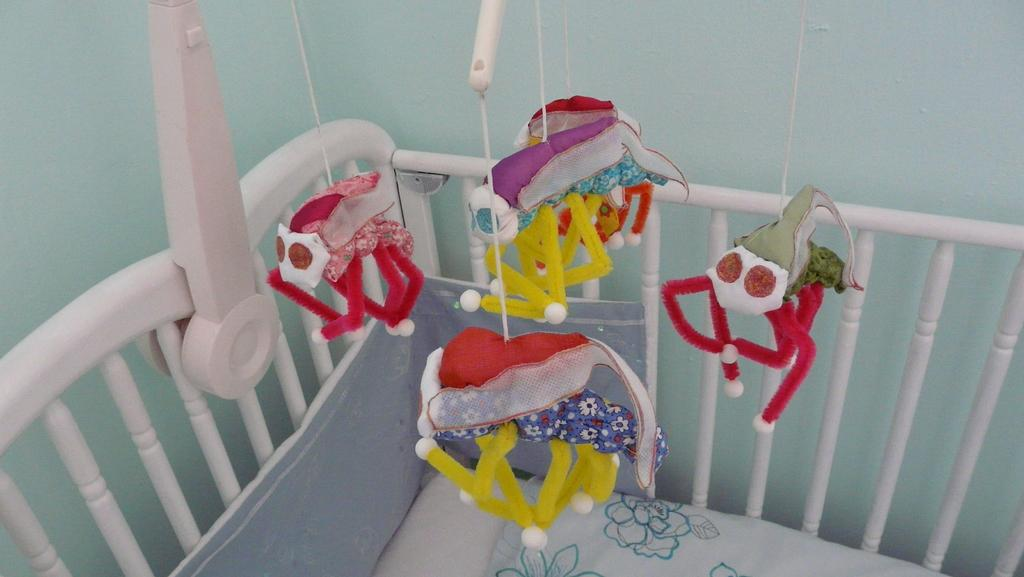What can be seen hanging in the image? There are toys hanging in the image. What type of furniture is present in the image? There is a cradle in the image. What type of judge is present in the image? There is no judge present in the image. What type of pleasure can be seen in the image? There is no specific pleasure depicted in the image; it features toys hanging and a cradle. 